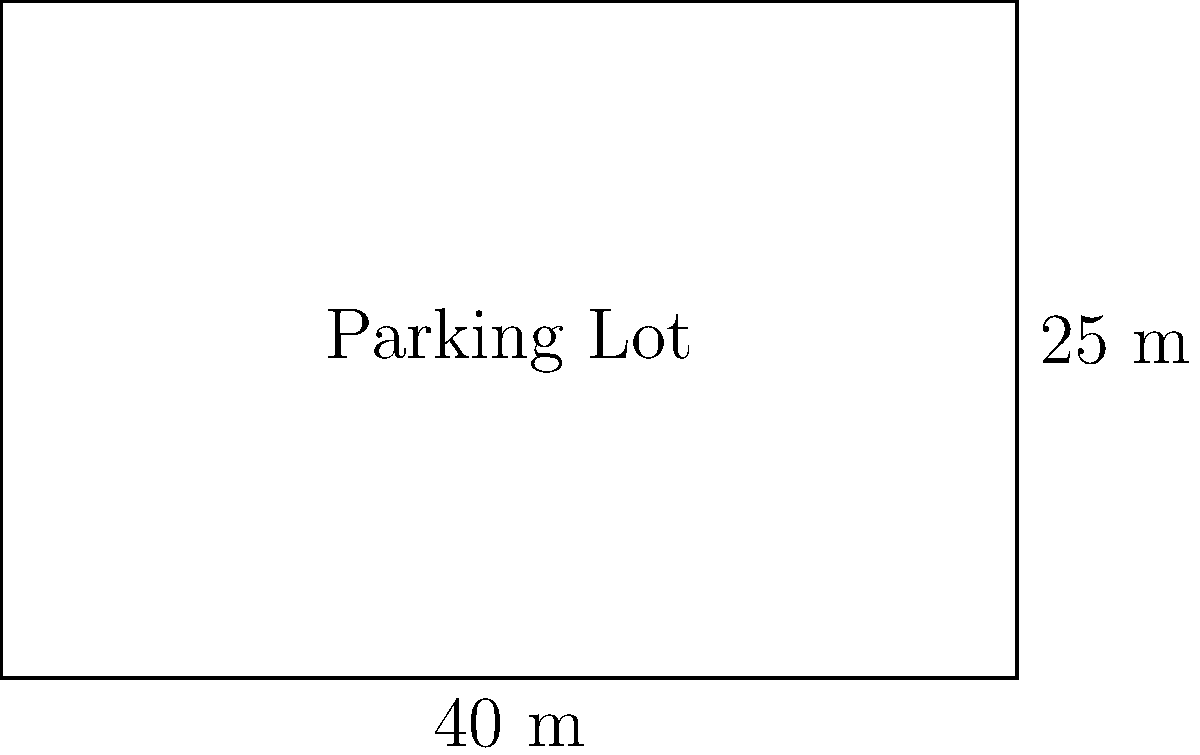The local police station needs to resurface its rectangular parking lot. The lot measures 40 meters in length and 25 meters in width. What is the total area of the parking lot that needs to be resurfaced? To find the area of a rectangular parking lot, we need to multiply its length by its width. Let's follow these steps:

1. Identify the given dimensions:
   - Length = 40 meters
   - Width = 25 meters

2. Use the formula for the area of a rectangle:
   Area = Length × Width

3. Substitute the values into the formula:
   Area = 40 m × 25 m

4. Perform the multiplication:
   Area = 1000 m²

Therefore, the total area of the parking lot that needs to be resurfaced is 1000 square meters.
Answer: 1000 m² 